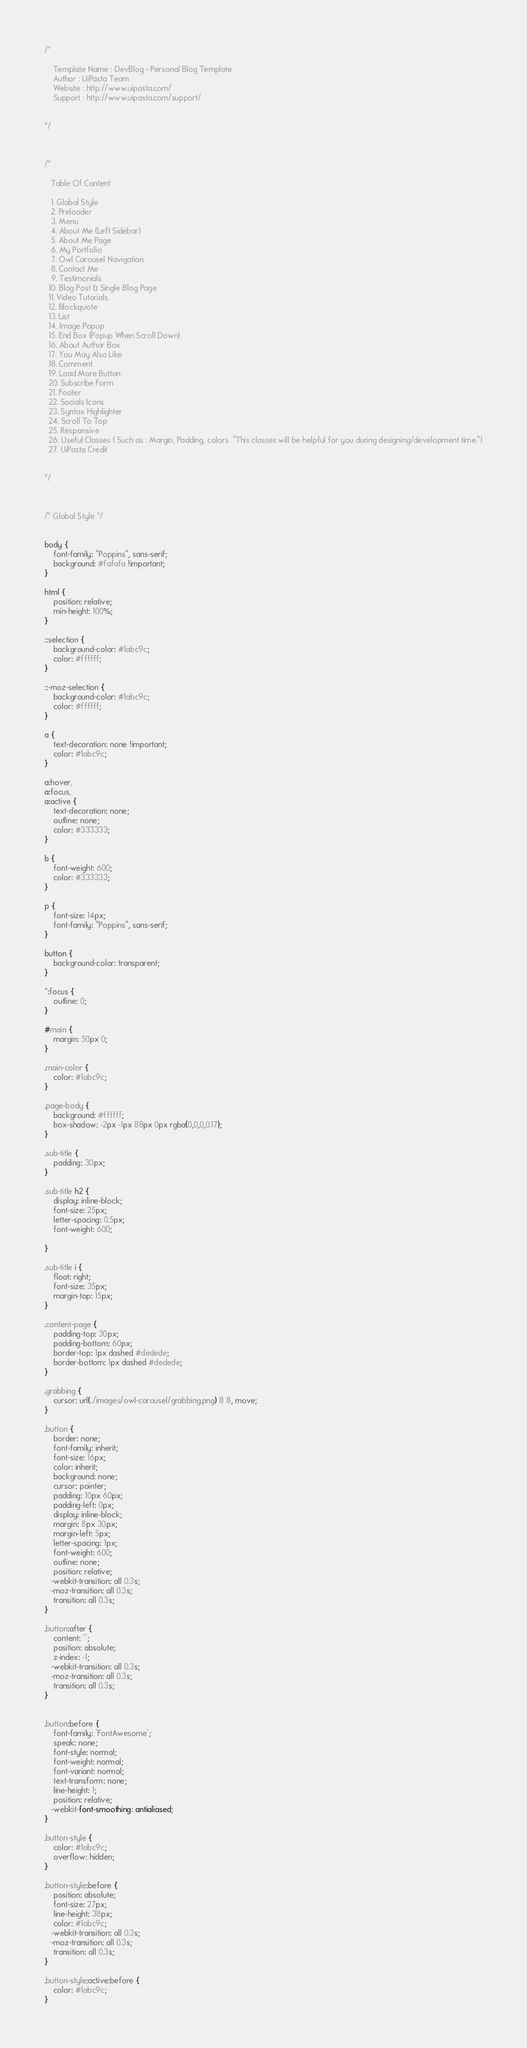<code> <loc_0><loc_0><loc_500><loc_500><_CSS_>/*
   
    Template Name : DevBlog - Personal Blog Template
    Author : UiPasta Team
    Website : http://www.uipasta.com/
    Support : http://www.uipasta.com/support/
	
	
*/



/*
   
   Table Of Content
   
   1. Global Style
   2. Preloader
   3. Menu
   4. About Me (Left Sidebar)
   5. About Me Page
   6. My Portfolio
   7. Owl Carousel Navigation
   8. Contact Me
   9. Testimonials
  10. Blog Post & Single Blog Page
  11. Video Tutorials
  12. Blockquote
  13. List
  14. Image Popup
  15. End Box (Popup When Scroll Down)
  16. About Author Box
  17. You May Also Like
  18. Comment
  19. Load More Button
  20. Subscribe Form
  21. Footer
  22. Socials Icons
  23. Syntax Highlighter
  24. Scroll To Top
  25. Responsive
  26. Useful Classes ( Such as : Margin, Padding, colors  "This classes will be helpful for you during designing/development time.")
  27. UiPasta Credit
 

*/



/* Global Style */


body {
    font-family: "Poppins", sans-serif;
    background: #fafafa !important;
}
	
html {
    position: relative;
    min-height: 100%;
}

::selection {
    background-color: #1abc9c;
    color: #ffffff;
}

::-moz-selection {
    background-color: #1abc9c;
    color: #ffffff;
}

a {
    text-decoration: none !important;
    color: #1abc9c;
}

a:hover,
a:focus,
a:active {
    text-decoration: none;
    outline: none;
    color: #333333;
}

b {
    font-weight: 600;
    color: #333333;
}

p {
    font-size: 14px;
    font-family: "Poppins", sans-serif;
}

button {
    background-color: transparent;
}

*:focus {
    outline: 0;
}

#main {
    margin: 50px 0;
}

.main-color {
    color: #1abc9c;
}

.page-body {
    background: #ffffff;
    box-shadow: -2px -1px 88px 0px rgba(0,0,0,0.17);
}

.sub-title {
    padding: 30px;
}

.sub-title h2 {
    display: inline-block;
    font-size: 25px;
    letter-spacing: 0.5px;
    font-weight: 600;

}

.sub-title i {
    float: right;
    font-size: 35px;
    margin-top: 15px;
}

.content-page {
    padding-top: 30px;
    padding-bottom: 60px;
    border-top: 1px dashed #dedede;
    border-bottom: 1px dashed #dedede;
}

.grabbing {
    cursor: url(../images/owl-carousel/grabbing.png) 8 8, move;
}

.button {
    border: none;
    font-family: inherit;
    font-size: 16px;
    color: inherit;
    background: none;
    cursor: pointer;
    padding: 10px 60px;
    padding-left: 0px;
    display: inline-block;
    margin: 8px 30px;
    margin-left: 5px;
    letter-spacing: 1px;
    font-weight: 600;
    outline: none;
    position: relative;
   -webkit-transition: all 0.3s;
   -moz-transition: all 0.3s;
    transition: all 0.3s;
}

.button:after {
    content: '';
    position: absolute;
    z-index: -1;
   -webkit-transition: all 0.3s;
   -moz-transition: all 0.3s;
    transition: all 0.3s;
}


.button:before {
    font-family: 'FontAwesome';
    speak: none;
    font-style: normal;
    font-weight: normal;
    font-variant: normal;
    text-transform: none;
    line-height: 1;
    position: relative;
   -webkit-font-smoothing: antialiased;
}

.button-style {
    color: #1abc9c;
    overflow: hidden;
}

.button-style:before {
    position: absolute;
    font-size: 27px;
    line-height: 38px;
    color: #1abc9c;
   -webkit-transition: all 0.3s;
   -moz-transition: all 0.3s;
    transition: all 0.3s;
}

.button-style:active:before {
    color: #1abc9c;
}
</code> 